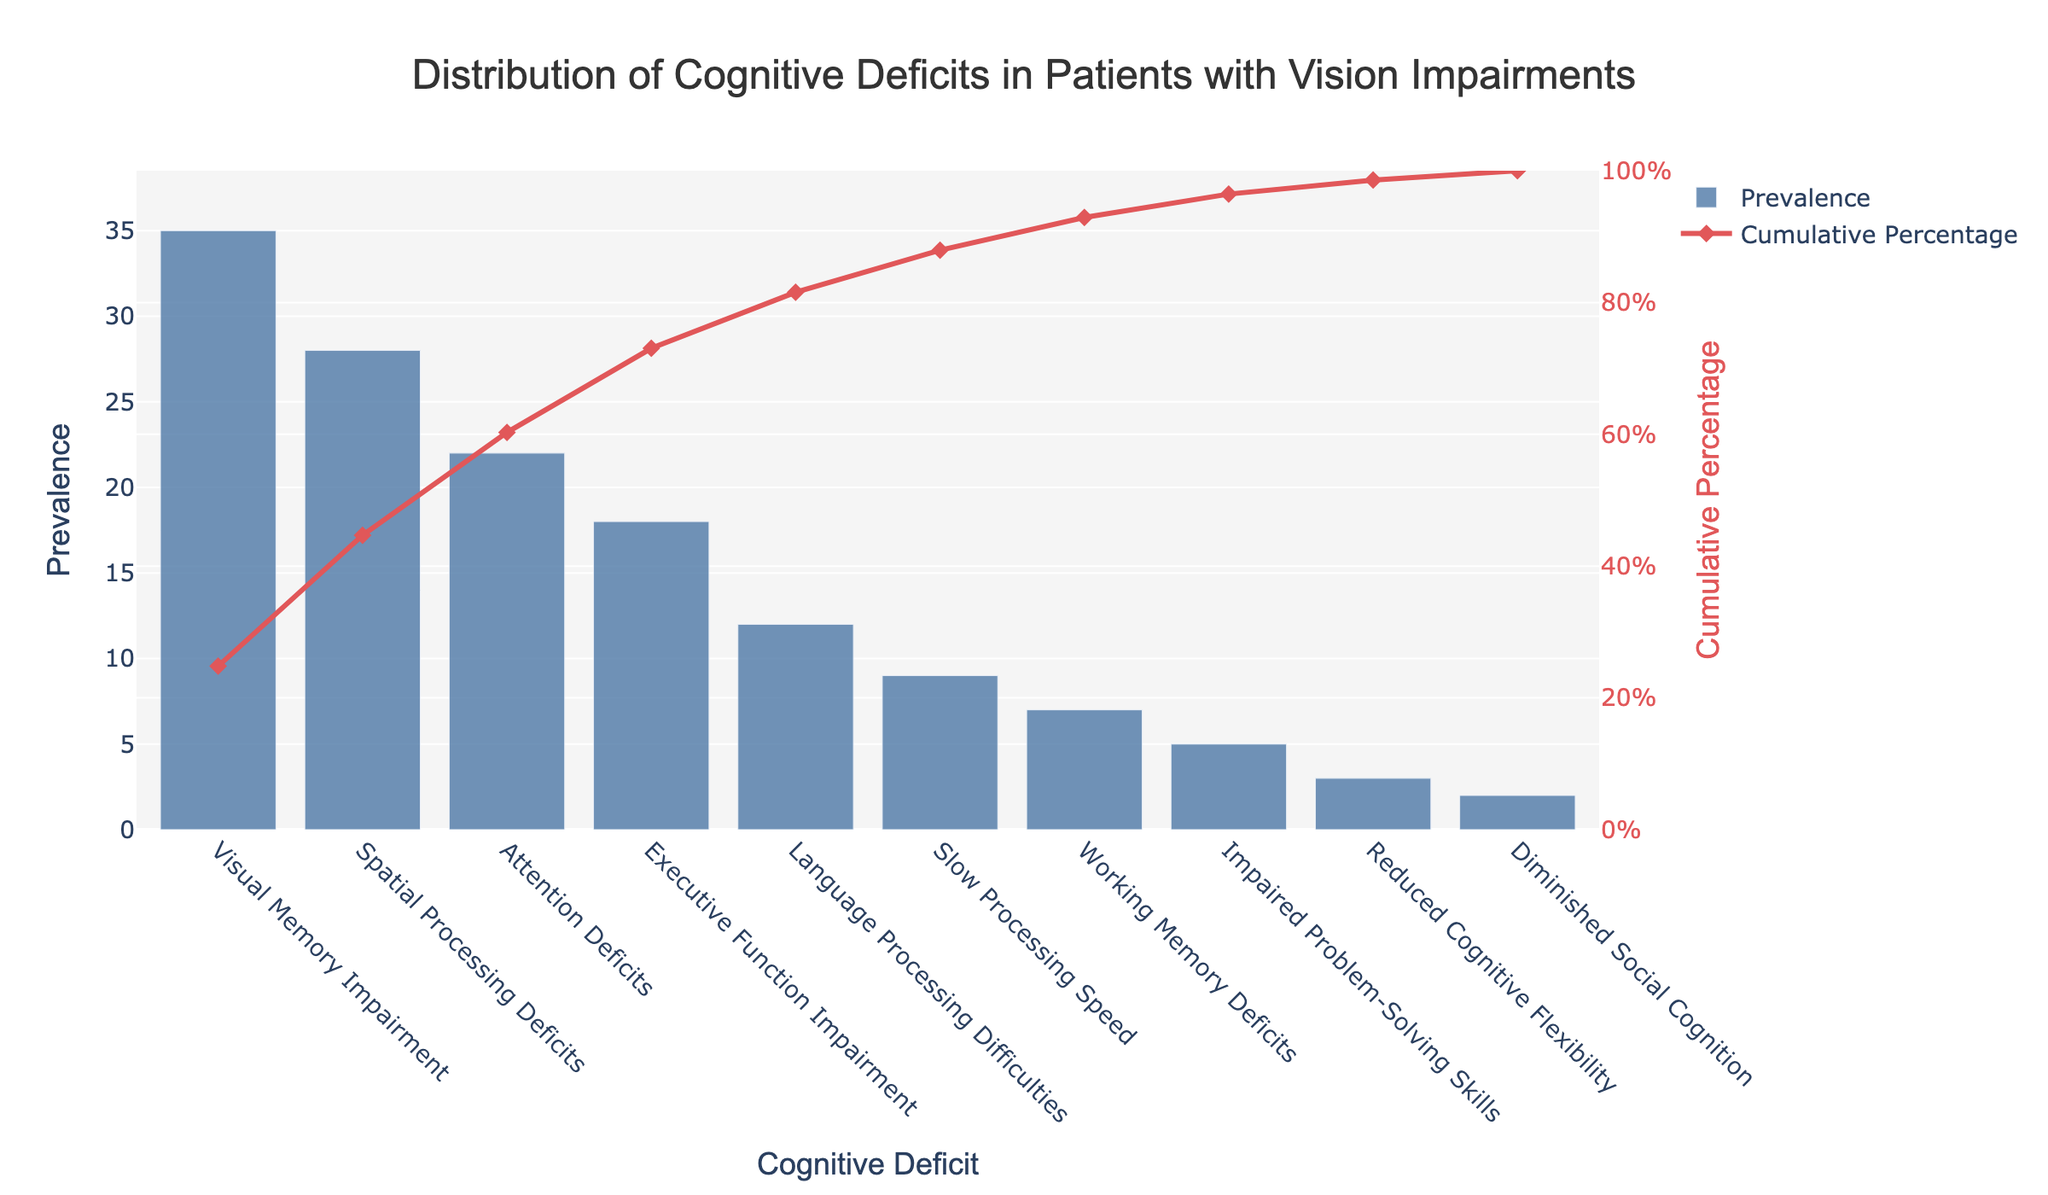What is the most prevalent cognitive deficit observed in patients with vision impairments? The bar chart shows the prevalence of each cognitive deficit. The highest bar represents the most prevalent deficit, which is Visual Memory Impairment with a value of 35.
Answer: Visual Memory Impairment What is the cumulative percentage of the two most prevalent cognitive deficits? Sum the prevalence of the two most prevalent deficits (Visual Memory Impairment: 35, Spatial Processing Deficits: 28) and find their cumulative percentage from the line chart. 35 + 28 = 63. According to the chart, the cumulative percentage for these two deficits is 63%.
Answer: 63% Which cognitive deficit has the lowest prevalence, and what is its value? Identify the shortest bar in the bar chart, which represents the least prevalent deficit. The shortest bar stands for Diminished Social Cognition with a value of 2.
Answer: Diminished Social Cognition What percentage of the total prevalence is contributed by the top three most prevalent cognitive deficits? Sum the prevalence values of the top three deficits (Visual Memory Impairment: 35, Spatial Processing Deficits: 28, Attention Deficits: 22). Calculate the percentage of this sum out of the total prevalence. (35 + 28 + 22) / 141 * 100 = 60.3%.
Answer: 60.3% How many cognitive deficits have a prevalence greater than 10? Count the bars in the bar chart that have a prevalence greater than 10. These are Visual Memory Impairment, Spatial Processing Deficits, Attention Deficits, and Executive Function Impairment. There are four such deficits.
Answer: 4 What is the prevalence of Slow Processing Speed, and how does it compare to Working Memory Deficits? Locate the bars representing Slow Processing Speed and Working Memory Deficits. Slow Processing Speed has a prevalence of 9, while Working Memory Deficits have a prevalence of 7. 9 is greater than 7.
Answer: 9, greater than 7 At what cumulative percentage does the prevalence of Executive Function Impairment fall? Find the bar representing Executive Function Impairment and look at the corresponding point on the cumulative percentage line chart. Executive Function Impairment has a cumulative percentage of 75%.
Answer: 75% Which two cognitive deficits fall within the prevalence range of 5-10? Identify the bars that fall within the specified range. The bars for Slow Processing Speed and Impaired Problem-Solving Skills fall within the range of 5-10, with prevalences of 9 and 5, respectively.
Answer: Slow Processing Speed, Impaired Problem-Solving Skills 